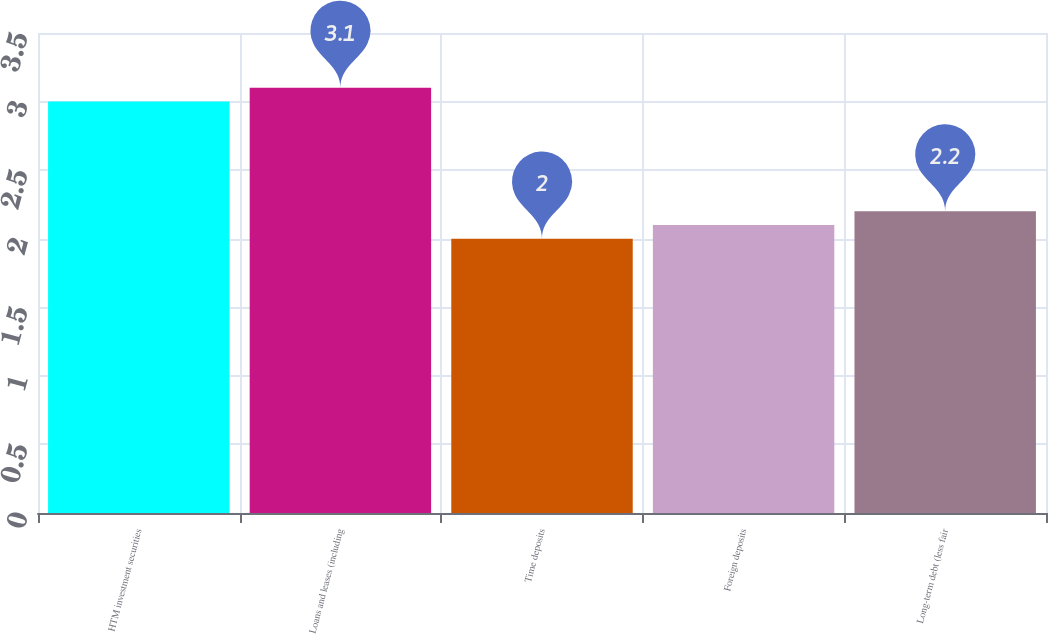Convert chart to OTSL. <chart><loc_0><loc_0><loc_500><loc_500><bar_chart><fcel>HTM investment securities<fcel>Loans and leases (including<fcel>Time deposits<fcel>Foreign deposits<fcel>Long-term debt (less fair<nl><fcel>3<fcel>3.1<fcel>2<fcel>2.1<fcel>2.2<nl></chart> 